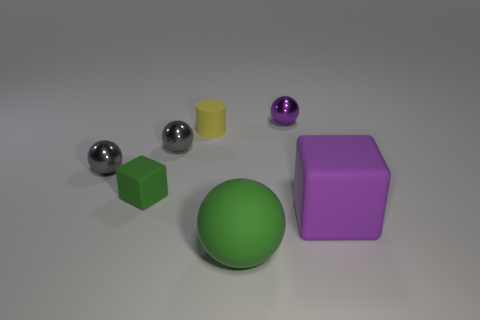Subtract all green spheres. How many spheres are left? 3 Subtract all cyan balls. Subtract all blue cylinders. How many balls are left? 4 Add 1 small shiny objects. How many objects exist? 8 Subtract all spheres. How many objects are left? 3 Add 4 cylinders. How many cylinders exist? 5 Subtract 0 blue cylinders. How many objects are left? 7 Subtract all purple metallic balls. Subtract all green metal objects. How many objects are left? 6 Add 2 yellow matte things. How many yellow matte things are left? 3 